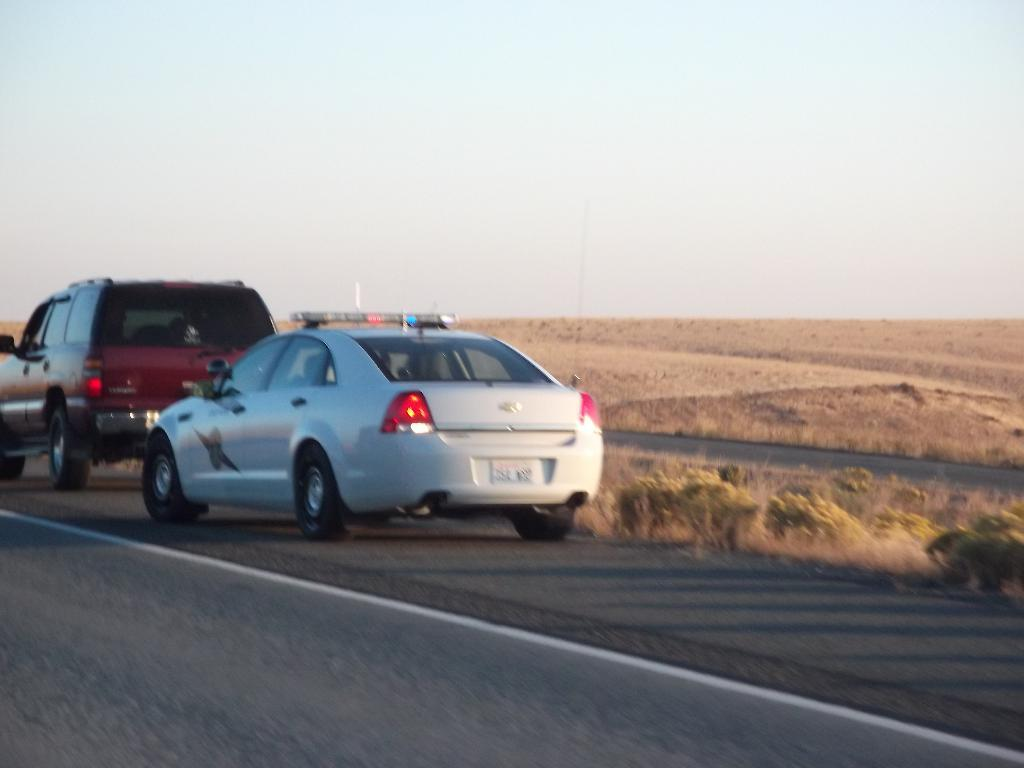What can be seen on the road in the image? There are cars on the road in the image. What type of vegetation is visible in the image? There is grass visible in the image. What is the condition of the sky in the image? The sky is cloudy in the image. Can you tell me how many wrens are perched on the bucket in the image? There is no bucket or wrens present in the image; it features cars on the road and grass. What type of condition is the bucket in within the image? There is no bucket present in the image, so it is not possible to determine its condition. 